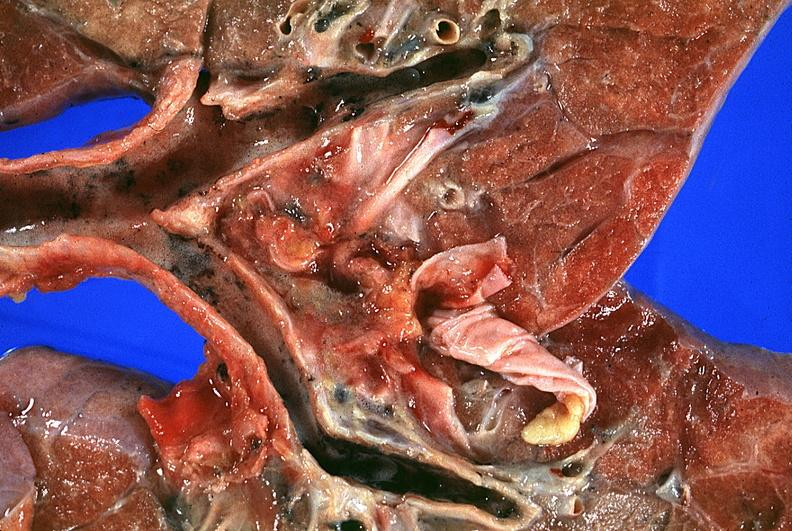do thermal burn smoke inhalation?
Answer the question using a single word or phrase. Yes 